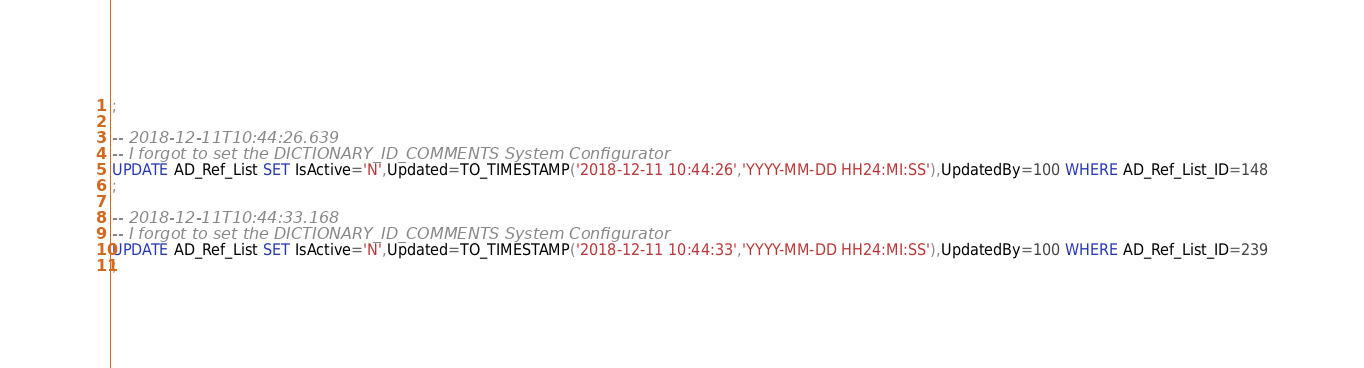<code> <loc_0><loc_0><loc_500><loc_500><_SQL_>;

-- 2018-12-11T10:44:26.639
-- I forgot to set the DICTIONARY_ID_COMMENTS System Configurator
UPDATE AD_Ref_List SET IsActive='N',Updated=TO_TIMESTAMP('2018-12-11 10:44:26','YYYY-MM-DD HH24:MI:SS'),UpdatedBy=100 WHERE AD_Ref_List_ID=148
;

-- 2018-12-11T10:44:33.168
-- I forgot to set the DICTIONARY_ID_COMMENTS System Configurator
UPDATE AD_Ref_List SET IsActive='N',Updated=TO_TIMESTAMP('2018-12-11 10:44:33','YYYY-MM-DD HH24:MI:SS'),UpdatedBy=100 WHERE AD_Ref_List_ID=239
;

</code> 